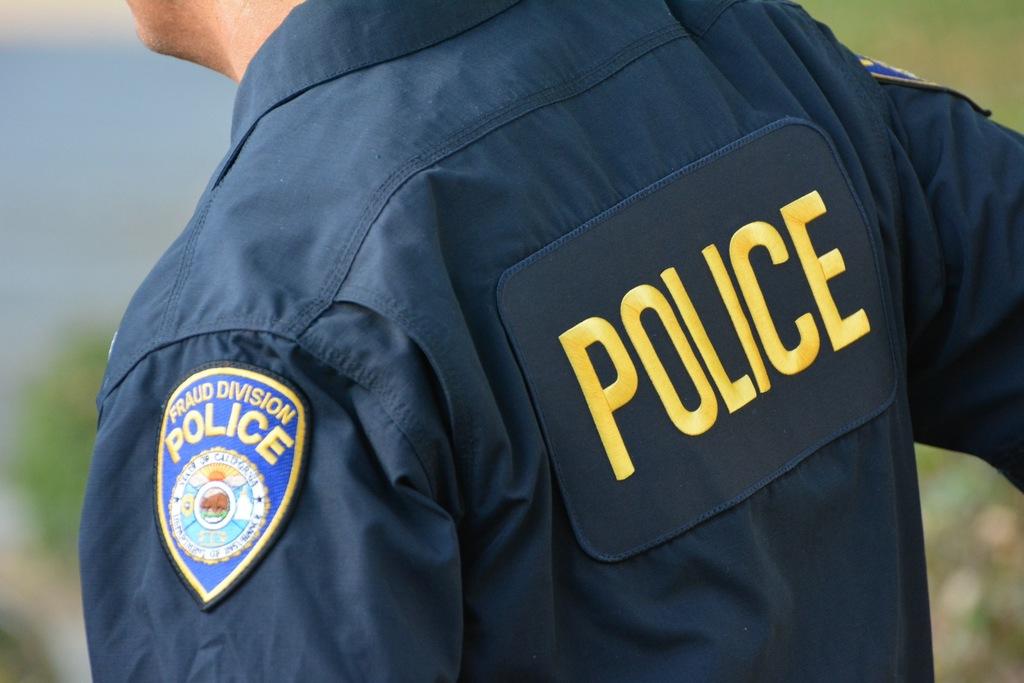What uniform is he wearing?
Your response must be concise. Police. 